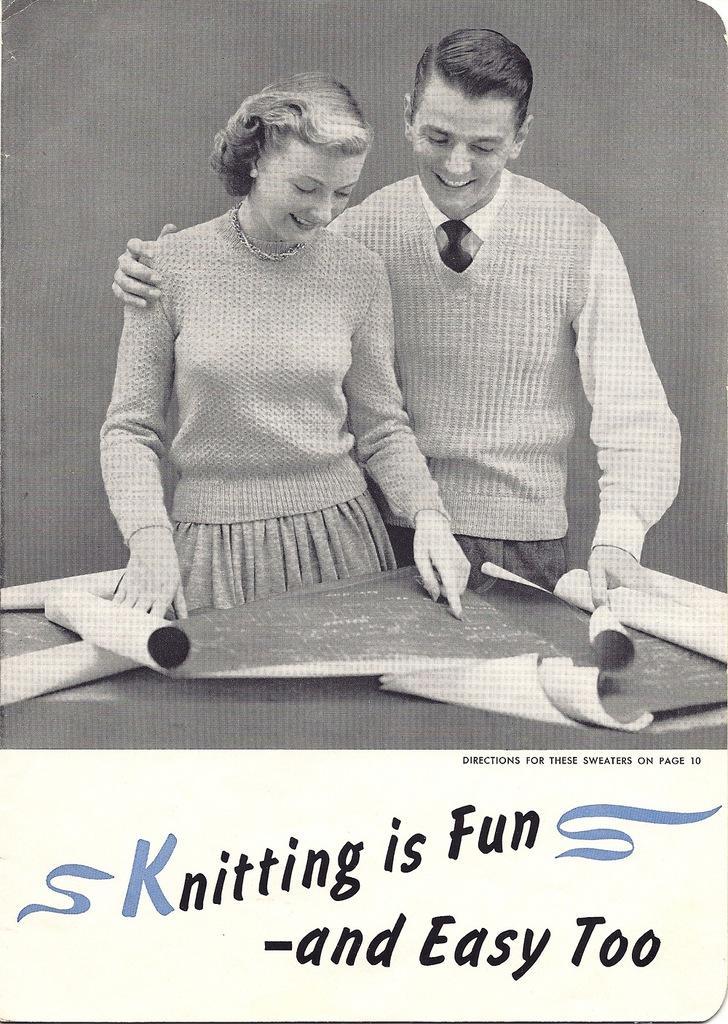In one or two sentences, can you explain what this image depicts? In this image I can see a man and woman holding few charts. At the bottom I can see some text. The image is in black and white color. 